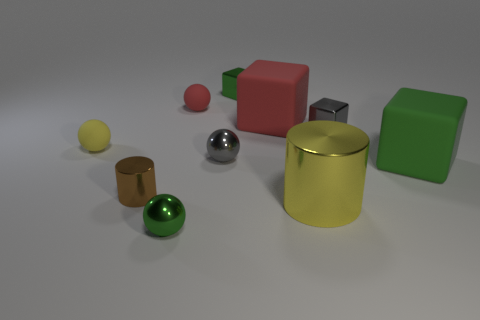Subtract all green metal spheres. How many spheres are left? 3 Subtract all balls. How many objects are left? 6 Subtract 1 cylinders. How many cylinders are left? 1 Subtract all yellow cylinders. How many cylinders are left? 1 Subtract all metal balls. Subtract all large shiny objects. How many objects are left? 7 Add 4 green shiny balls. How many green shiny balls are left? 5 Add 1 tiny yellow rubber spheres. How many tiny yellow rubber spheres exist? 2 Subtract 1 brown cylinders. How many objects are left? 9 Subtract all green balls. Subtract all yellow cylinders. How many balls are left? 3 Subtract all red cubes. How many gray spheres are left? 1 